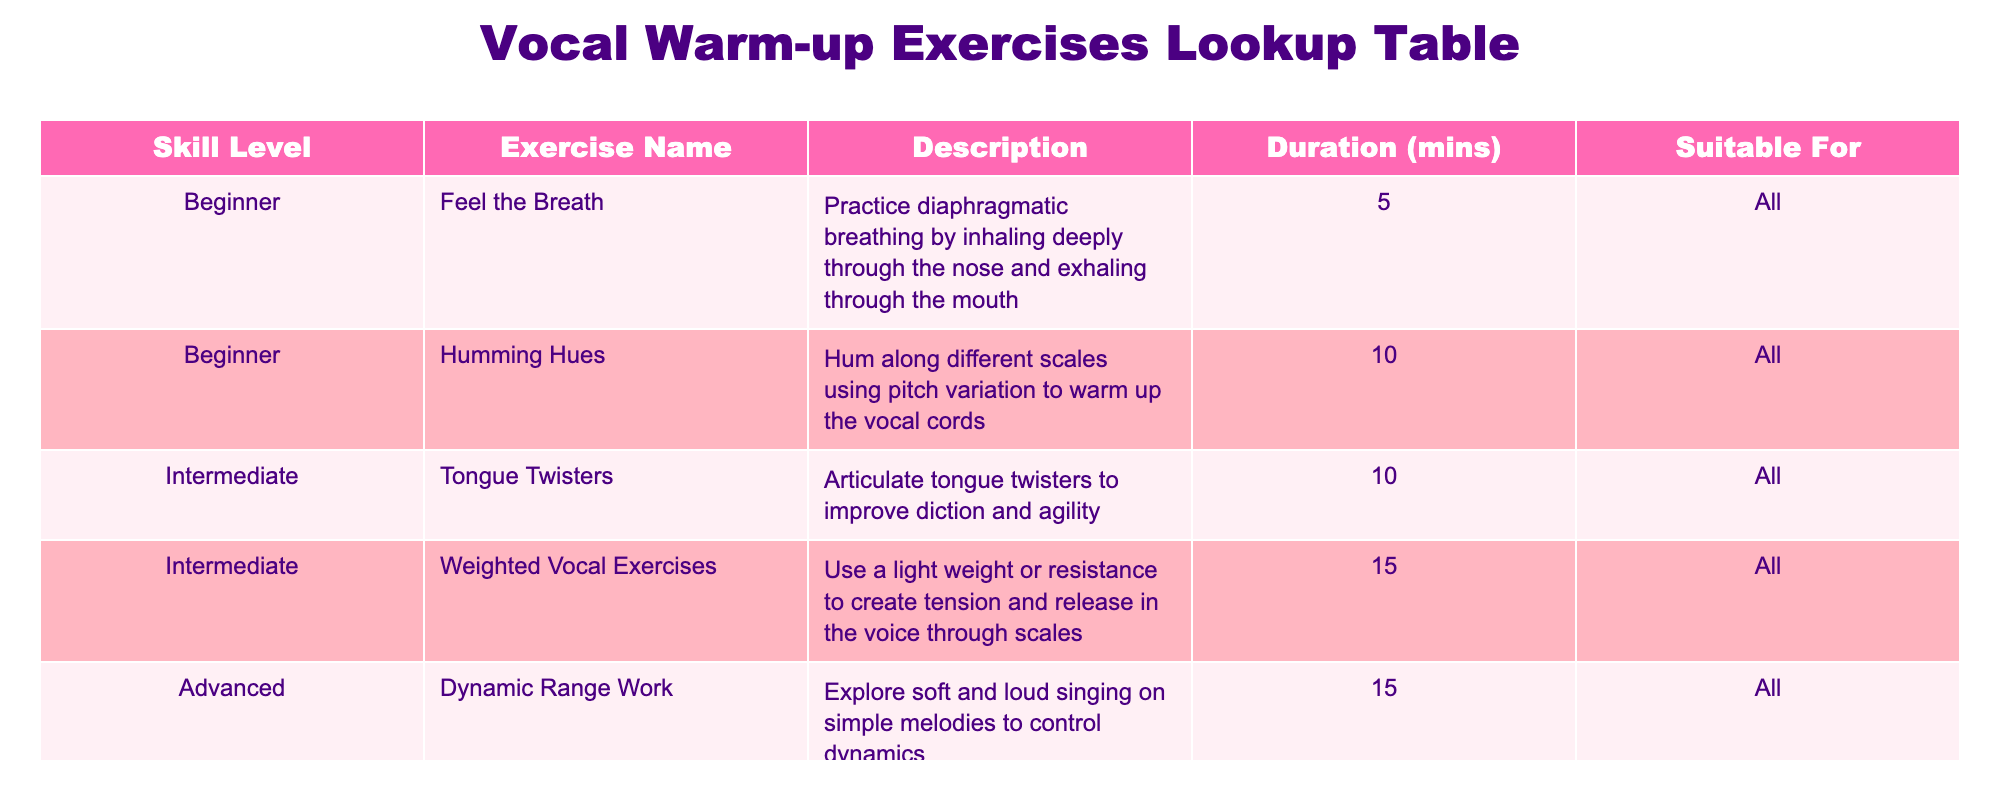What is the duration of the exercise "Humming Hues"? The table lists "Humming Hues" under the Beginner skill level with a duration of 10 minutes.
Answer: 10 minutes Which exercise is suitable for all skill levels? Looking at the "Suitable For" column, all exercises except "Dynamic Range Work" specify they are suitable for "All"; thus, the "Feel the Breath" and "Humming Hues" are among them.
Answer: Feel the Breath, Humming Hues, Tongue Twisters, Weighted Vocal Exercises How many exercises are categorized as Intermediate? By counting the entries under the "Skill Level" column for Intermediate, there are two exercises: "Tongue Twisters" and "Weighted Vocal Exercises."
Answer: 2 Is "Dynamic Range Work" suitable for beginners? "Dynamic Range Work" is categorized under advanced exercises in the "Skill Level" column, indicating it is not suitable for beginners.
Answer: No What is the average duration of the exercises listed in the table? To find the average duration, sum all durations: (5 + 10 + 10 + 15 + 15) = 55 minutes. There are 5 exercises, so the average is 55/5 = 11 minutes.
Answer: 11 minutes How many exercises focus on breathing techniques? In the table, only one exercise, "Feel the Breath," focuses specifically on breathing techniques as mentioned in the description.
Answer: 1 Are there any exercises that last less than 10 minutes? "Feel the Breath" is the only exercise that lasts 5 minutes, which is less than 10 minutes.
Answer: Yes What percentage of exercises are suitable for all levels? There are 4 exercises listed as suitable for "All" out of a total of 5 exercises, which gives a percentage of (4/5)*100 = 80%.
Answer: 80% 